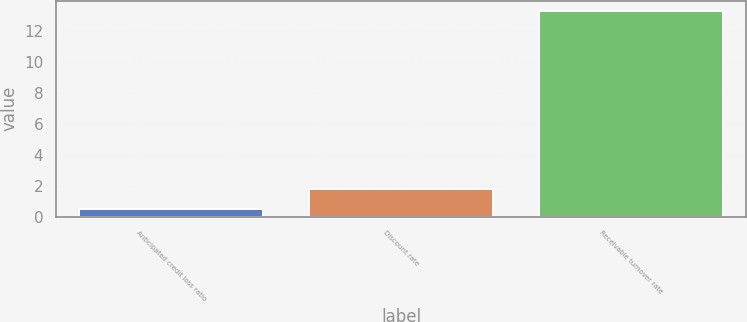<chart> <loc_0><loc_0><loc_500><loc_500><bar_chart><fcel>Anticipated credit loss ratio<fcel>Discount rate<fcel>Receivable turnover rate<nl><fcel>0.5<fcel>1.78<fcel>13.3<nl></chart> 